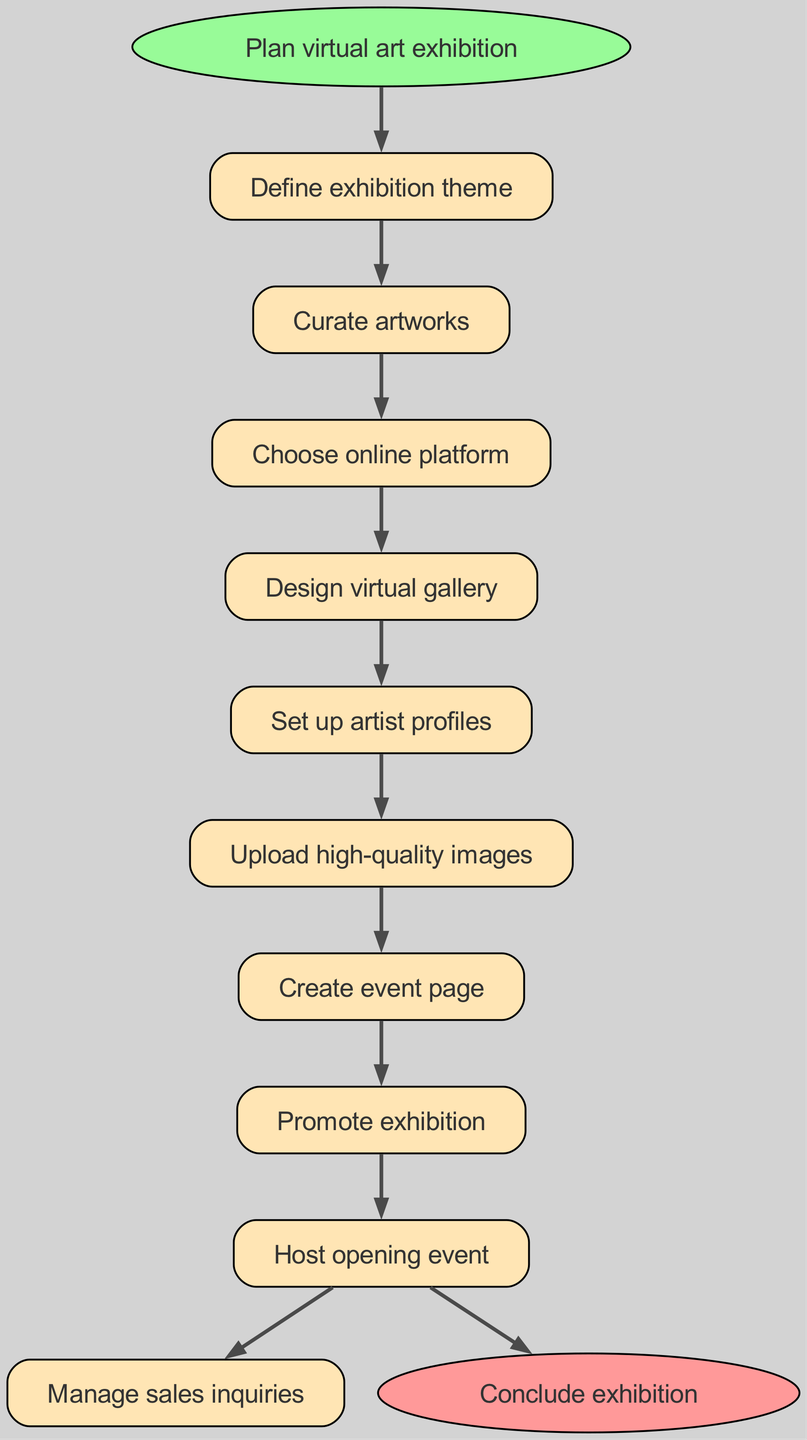What is the first step in the exhibition? The diagram begins with the node labeled "Plan virtual art exhibition," which indicates this is the initial step in the process.
Answer: Plan virtual art exhibition How many steps are in the exhibition process? By counting the individual nodes listed in the steps portion, there are 8 distinct steps before reaching the conclusion node.
Answer: 8 What is the final action taken in the exhibition flow? The last node in the flow chart is "Conclude exhibition," which signifies the end of the process after all prior steps are followed.
Answer: Conclude exhibition What is the step that follows "Create event page"? In the chart, "Promote exhibition" is the step that directly follows "Create event page," showing the progression in the flow.
Answer: Promote exhibition Which step involves managing sales inquiries? The flow chart explicitly states "Manage sales inquiries" as a step that comes after "Host opening event." This indicates the order of actions in the process.
Answer: Manage sales inquiries What two nodes are connected by an edge after “Upload high-quality images”? In the diagram, "Upload high-quality images" connects to "Create event page," showing a direct relationship between these two steps.
Answer: Create event page What is the third step in the organized sequence? By tracing through the steps sequentially, the third action is "Choose online platform," which shows the process's structure more clearly.
Answer: Choose online platform What connects the "Design virtual gallery" step to the next step? The diagram displays an edge from "Design virtual gallery" to "Set up artist profiles," indicating the direct flow from one step to the next.
Answer: Set up artist profiles What is indicated by the start and end nodes? The start node establishes the initiation of the process ("Plan virtual art exhibition"), while the end node signifies the conclusion of the entire exhibition process ("Conclude exhibition").
Answer: Plan virtual art exhibition and Conclude exhibition 